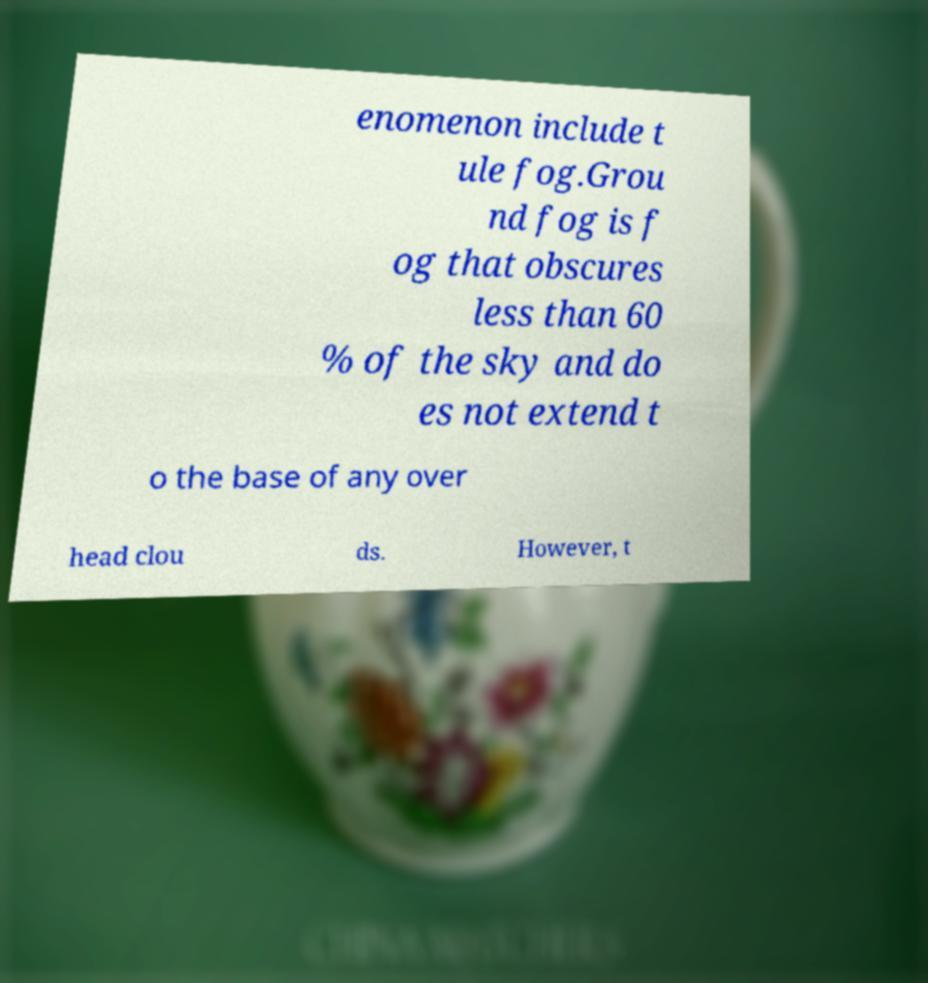There's text embedded in this image that I need extracted. Can you transcribe it verbatim? enomenon include t ule fog.Grou nd fog is f og that obscures less than 60 % of the sky and do es not extend t o the base of any over head clou ds. However, t 